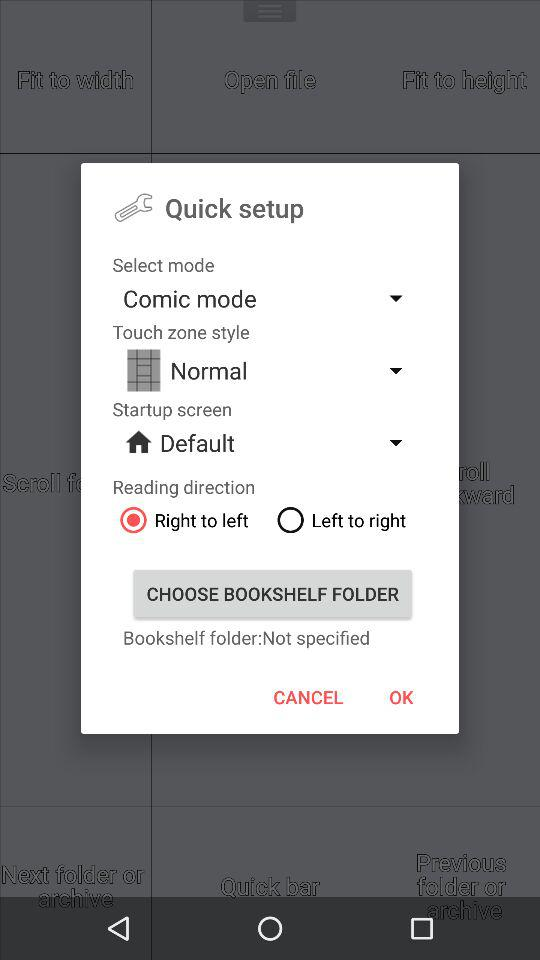Is "Bookshelf folder" specified or not? "Bookshelf folder" is not specified. 